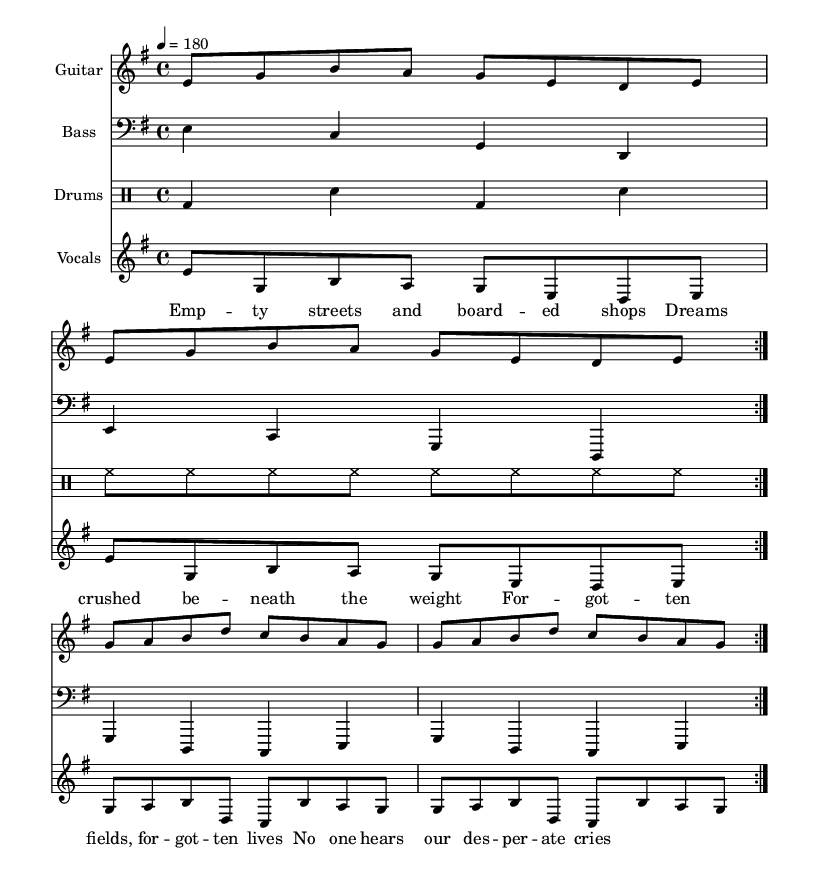What is the key signature of this music? The key signature is based on the list of sharps and flats at the beginning of the music, which in this case shows one sharp, indicating the key of E minor.
Answer: E minor What is the time signature of this music? The time signature is indicated at the beginning of the score. Here, it shows "4/4," which indicates that there are four beats in each measure and the quarter note receives one beat.
Answer: 4/4 What is the tempo marking of this music? The tempo marking is found above the staff and indicates the speed of the piece. In this case, it is marked as "4 = 180," which means there are 180 quarter notes per minute.
Answer: 180 How many measures are repeated in the guitar part? The guitar part has a repeat sign indicated by "volta 2," meaning that the section is to be played twice.
Answer: Two What texture does this punk track create with its instrumentation? The punk track features a combination of electric guitar, bass guitar, drums, and vocals, suggesting a loud and cohesive sound typical in punk music, often creating a dense texture.
Answer: Dense texture What themes do the lyrics of this music address? The lyrics refer to social issues related to desolation and being forgotten in rural areas, indicating themes of despair and social commentary, characteristic of punk music's focus on social issues.
Answer: Social issues 